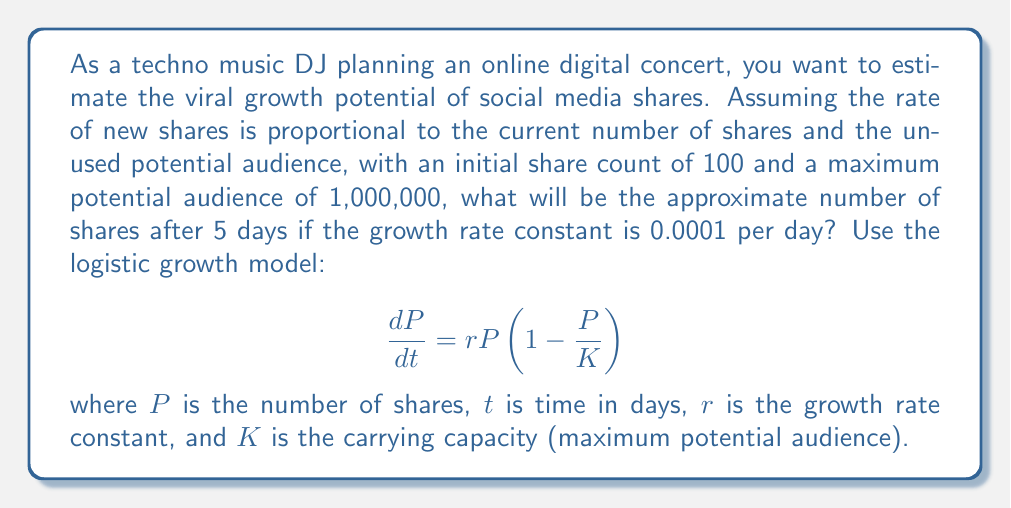Can you solve this math problem? To solve this problem, we'll use the logistic growth model, which is a nonlinear dynamical system. The solution to this differential equation is given by:

$$P(t) = \frac{K}{1 + (\frac{K}{P_0} - 1)e^{-rt}}$$

Where:
$P(t)$ is the number of shares at time $t$
$K = 1,000,000$ (carrying capacity)
$P_0 = 100$ (initial number of shares)
$r = 0.0001$ (growth rate constant)
$t = 5$ (time in days)

Let's substitute these values into the equation:

$$P(5) = \frac{1,000,000}{1 + (\frac{1,000,000}{100} - 1)e^{-0.0001 \cdot 5}}$$

$$= \frac{1,000,000}{1 + (9999)e^{-0.0005}}$$

$$= \frac{1,000,000}{1 + 9999 \cdot 0.99950}$$

$$= \frac{1,000,000}{1 + 9994.00}$$

$$= \frac{1,000,000}{9995.00}$$

$$\approx 100.05$$

Therefore, after 5 days, the approximate number of shares will be 100 (rounded to the nearest whole number).
Answer: 100 shares 